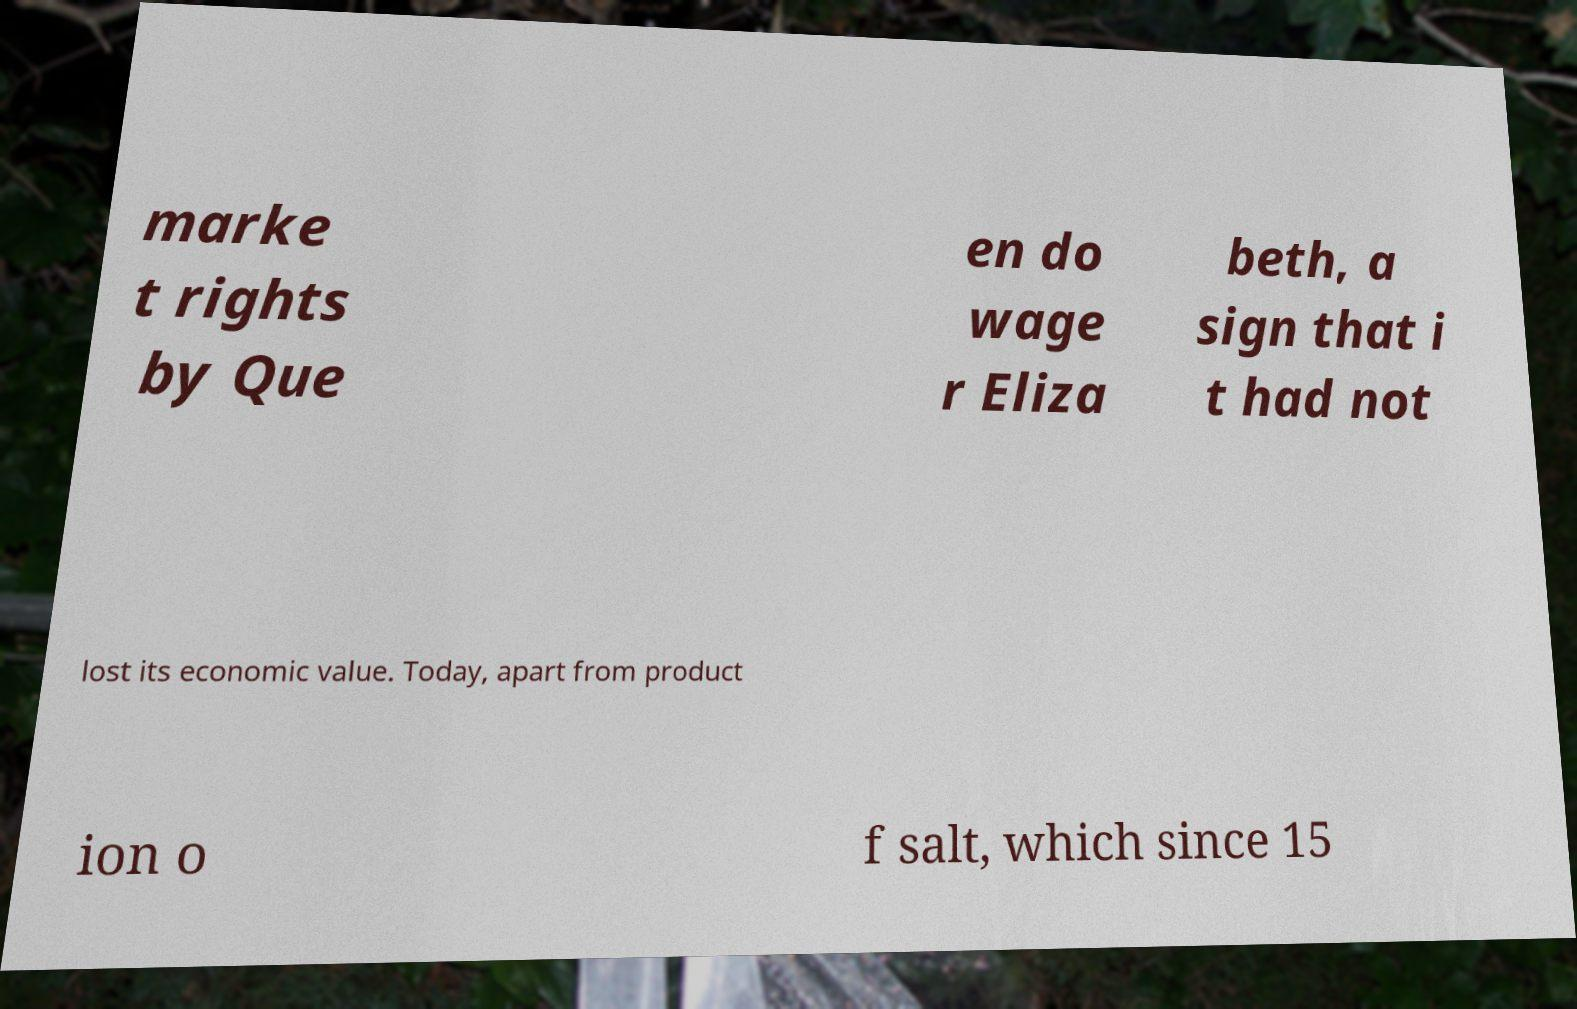Can you read and provide the text displayed in the image?This photo seems to have some interesting text. Can you extract and type it out for me? marke t rights by Que en do wage r Eliza beth, a sign that i t had not lost its economic value. Today, apart from product ion o f salt, which since 15 